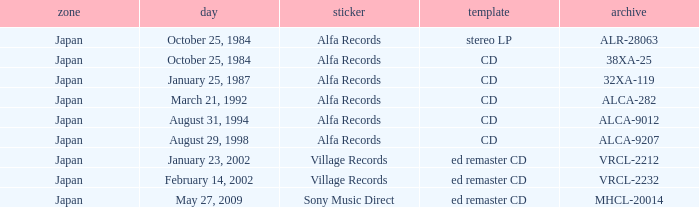Could you help me parse every detail presented in this table? {'header': ['zone', 'day', 'sticker', 'template', 'archive'], 'rows': [['Japan', 'October 25, 1984', 'Alfa Records', 'stereo LP', 'ALR-28063'], ['Japan', 'October 25, 1984', 'Alfa Records', 'CD', '38XA-25'], ['Japan', 'January 25, 1987', 'Alfa Records', 'CD', '32XA-119'], ['Japan', 'March 21, 1992', 'Alfa Records', 'CD', 'ALCA-282'], ['Japan', 'August 31, 1994', 'Alfa Records', 'CD', 'ALCA-9012'], ['Japan', 'August 29, 1998', 'Alfa Records', 'CD', 'ALCA-9207'], ['Japan', 'January 23, 2002', 'Village Records', 'ed remaster CD', 'VRCL-2212'], ['Japan', 'February 14, 2002', 'Village Records', 'ed remaster CD', 'VRCL-2232'], ['Japan', 'May 27, 2009', 'Sony Music Direct', 'ed remaster CD', 'MHCL-20014']]} What Label released on October 25, 1984, in the format of Stereo LP? Alfa Records. 